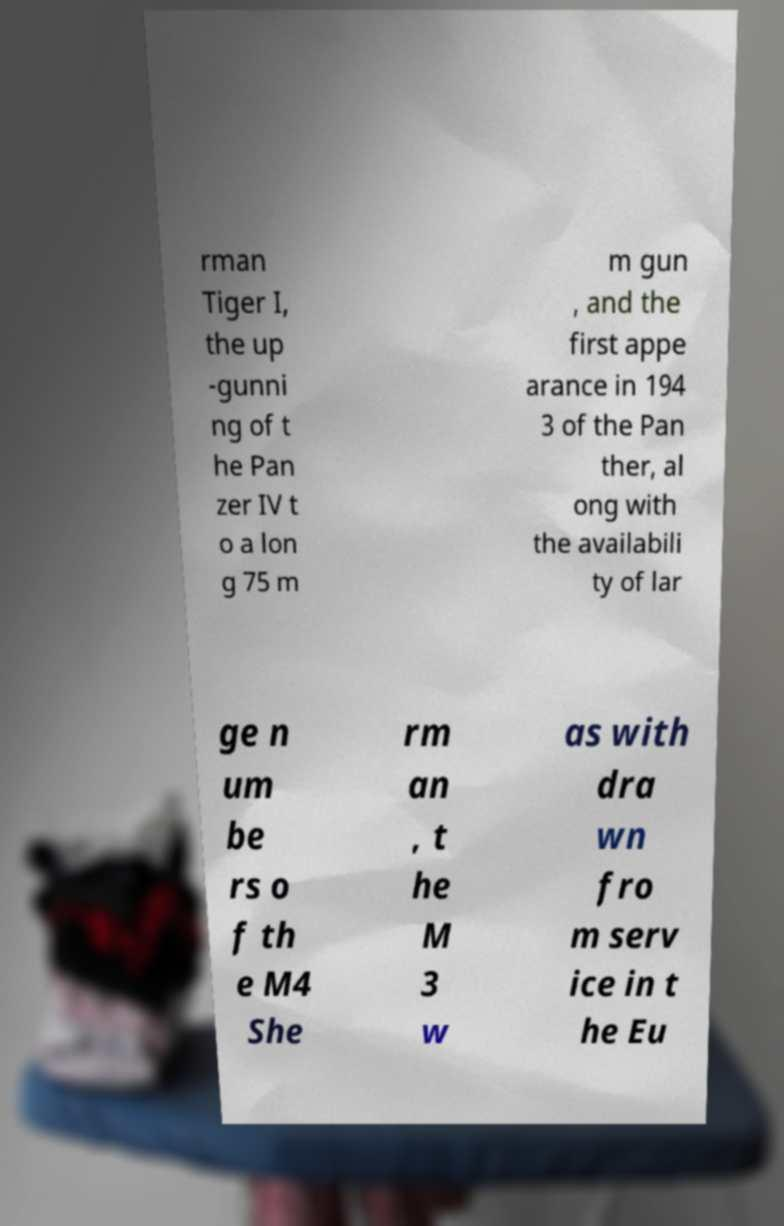There's text embedded in this image that I need extracted. Can you transcribe it verbatim? rman Tiger I, the up -gunni ng of t he Pan zer IV t o a lon g 75 m m gun , and the first appe arance in 194 3 of the Pan ther, al ong with the availabili ty of lar ge n um be rs o f th e M4 She rm an , t he M 3 w as with dra wn fro m serv ice in t he Eu 